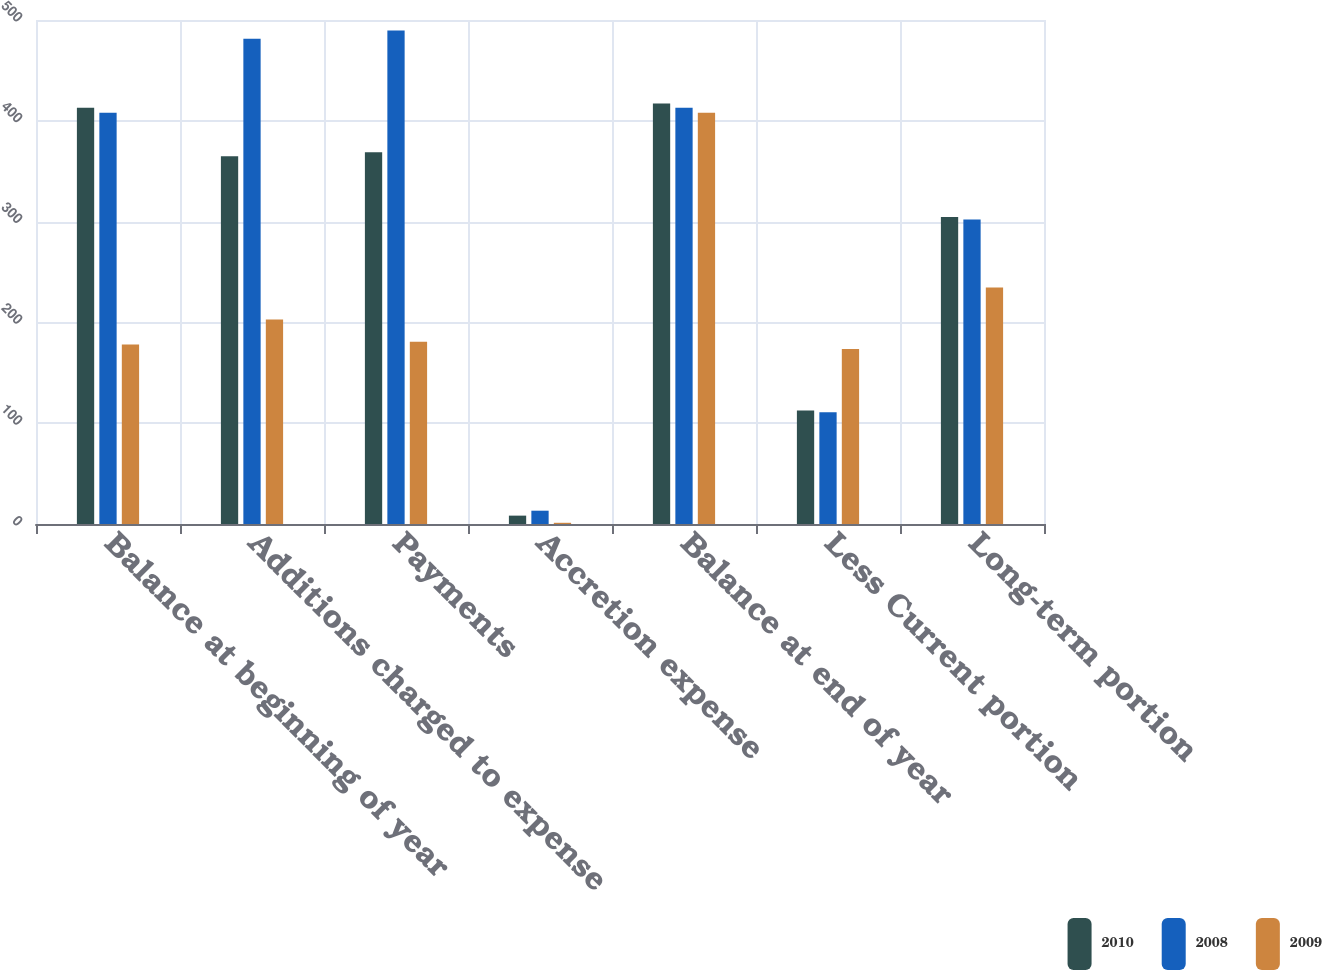Convert chart to OTSL. <chart><loc_0><loc_0><loc_500><loc_500><stacked_bar_chart><ecel><fcel>Balance at beginning of year<fcel>Additions charged to expense<fcel>Payments<fcel>Accretion expense<fcel>Balance at end of year<fcel>Less Current portion<fcel>Long-term portion<nl><fcel>2010<fcel>412.9<fcel>364.9<fcel>368.9<fcel>8.3<fcel>417.2<fcel>112.7<fcel>304.5<nl><fcel>2008<fcel>408.1<fcel>481.3<fcel>489.7<fcel>13.2<fcel>412.9<fcel>110.9<fcel>302<nl><fcel>2009<fcel>178<fcel>203<fcel>180.9<fcel>1.2<fcel>408.1<fcel>173.6<fcel>234.5<nl></chart> 